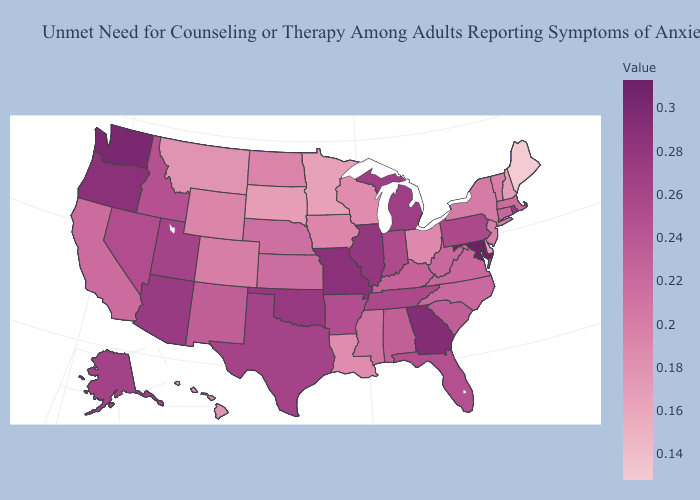Which states have the highest value in the USA?
Answer briefly. Maryland. Does Nebraska have the highest value in the MidWest?
Quick response, please. No. Which states have the lowest value in the MidWest?
Quick response, please. Minnesota. Which states have the lowest value in the USA?
Be succinct. Maine. Is the legend a continuous bar?
Short answer required. Yes. 